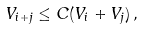<formula> <loc_0><loc_0><loc_500><loc_500>V _ { i + j } \leq C ( V _ { i } + V _ { j } ) \, ,</formula> 